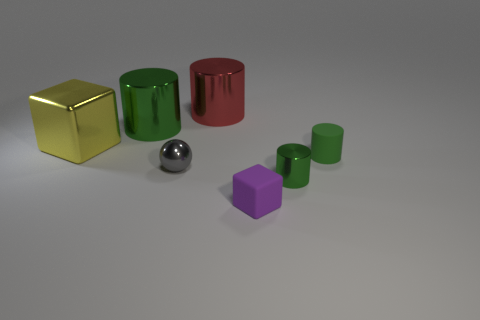Subtract all green cylinders. How many were subtracted if there are1green cylinders left? 2 Subtract all large green shiny cylinders. How many cylinders are left? 3 Subtract all cylinders. How many objects are left? 3 Subtract all large yellow cubes. Subtract all rubber objects. How many objects are left? 4 Add 2 large yellow metal cubes. How many large yellow metal cubes are left? 3 Add 6 big yellow metallic cubes. How many big yellow metallic cubes exist? 7 Add 3 large yellow shiny cubes. How many objects exist? 10 Subtract all red cylinders. How many cylinders are left? 3 Subtract 0 blue cubes. How many objects are left? 7 Subtract all red cylinders. Subtract all blue cubes. How many cylinders are left? 3 